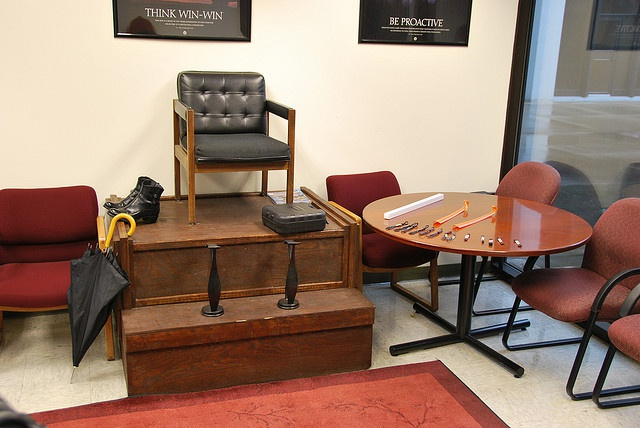Describe the objects in this image and their specific colors. I can see dining table in beige, tan, black, and brown tones, chair in beige, gray, black, and maroon tones, chair in beige, maroon, brown, and black tones, chair in beige, maroon, black, and brown tones, and chair in beige, maroon, black, brown, and gray tones in this image. 